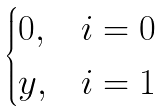Convert formula to latex. <formula><loc_0><loc_0><loc_500><loc_500>\begin{cases} 0 , & i = 0 \\ y , & i = 1 \end{cases}</formula> 